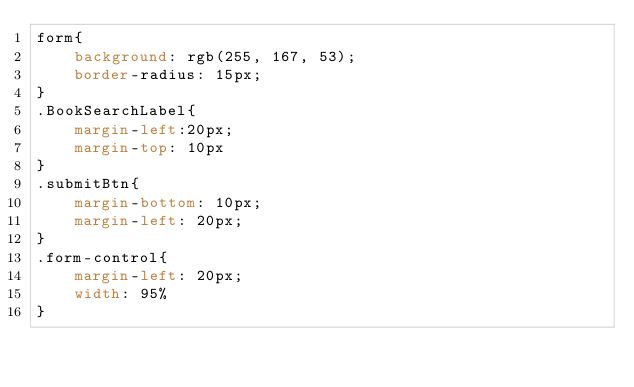<code> <loc_0><loc_0><loc_500><loc_500><_CSS_>form{
    background: rgb(255, 167, 53);
    border-radius: 15px;
}
.BookSearchLabel{
    margin-left:20px;
    margin-top: 10px
}
.submitBtn{
    margin-bottom: 10px;
    margin-left: 20px;
}
.form-control{
    margin-left: 20px;
    width: 95%
}</code> 